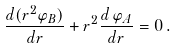Convert formula to latex. <formula><loc_0><loc_0><loc_500><loc_500>\frac { d ( r ^ { 2 } { \varphi } _ { B } ) } { d r } + r ^ { 2 } \frac { d \, \varphi _ { A } } { d r } = 0 \, .</formula> 